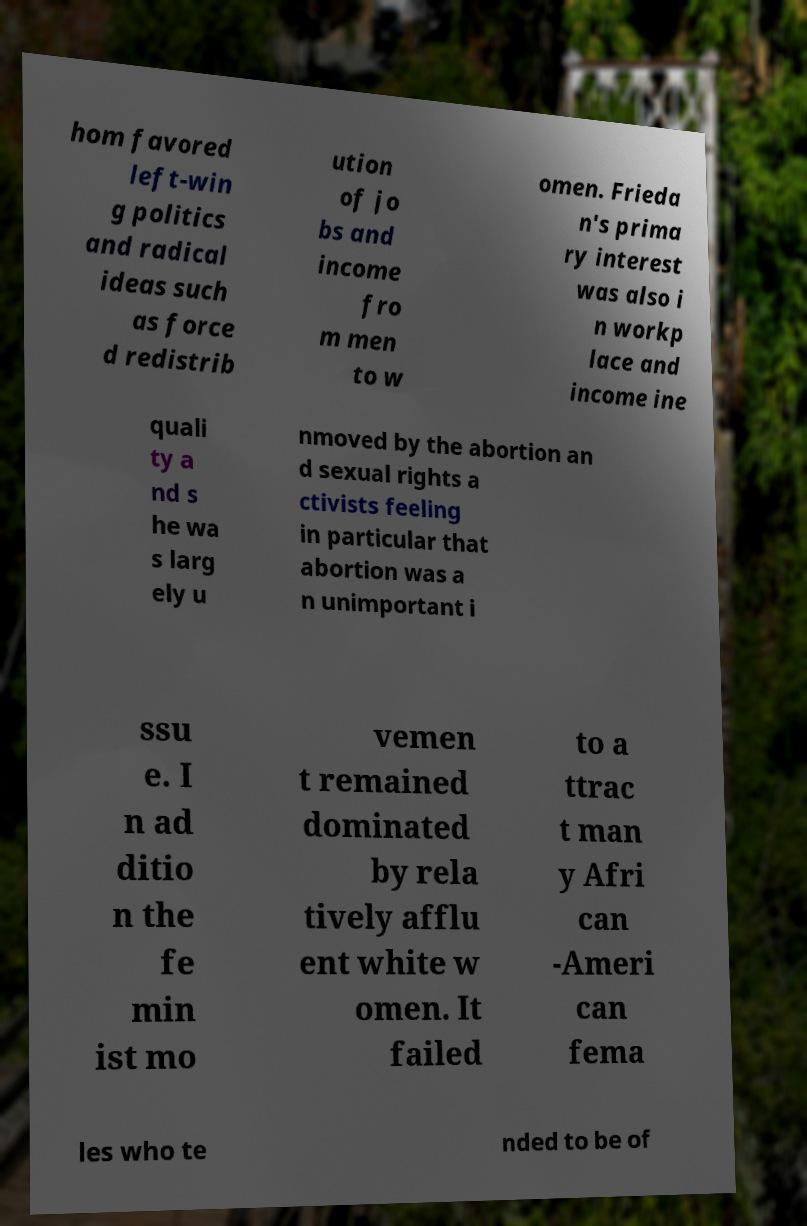For documentation purposes, I need the text within this image transcribed. Could you provide that? hom favored left-win g politics and radical ideas such as force d redistrib ution of jo bs and income fro m men to w omen. Frieda n's prima ry interest was also i n workp lace and income ine quali ty a nd s he wa s larg ely u nmoved by the abortion an d sexual rights a ctivists feeling in particular that abortion was a n unimportant i ssu e. I n ad ditio n the fe min ist mo vemen t remained dominated by rela tively afflu ent white w omen. It failed to a ttrac t man y Afri can -Ameri can fema les who te nded to be of 